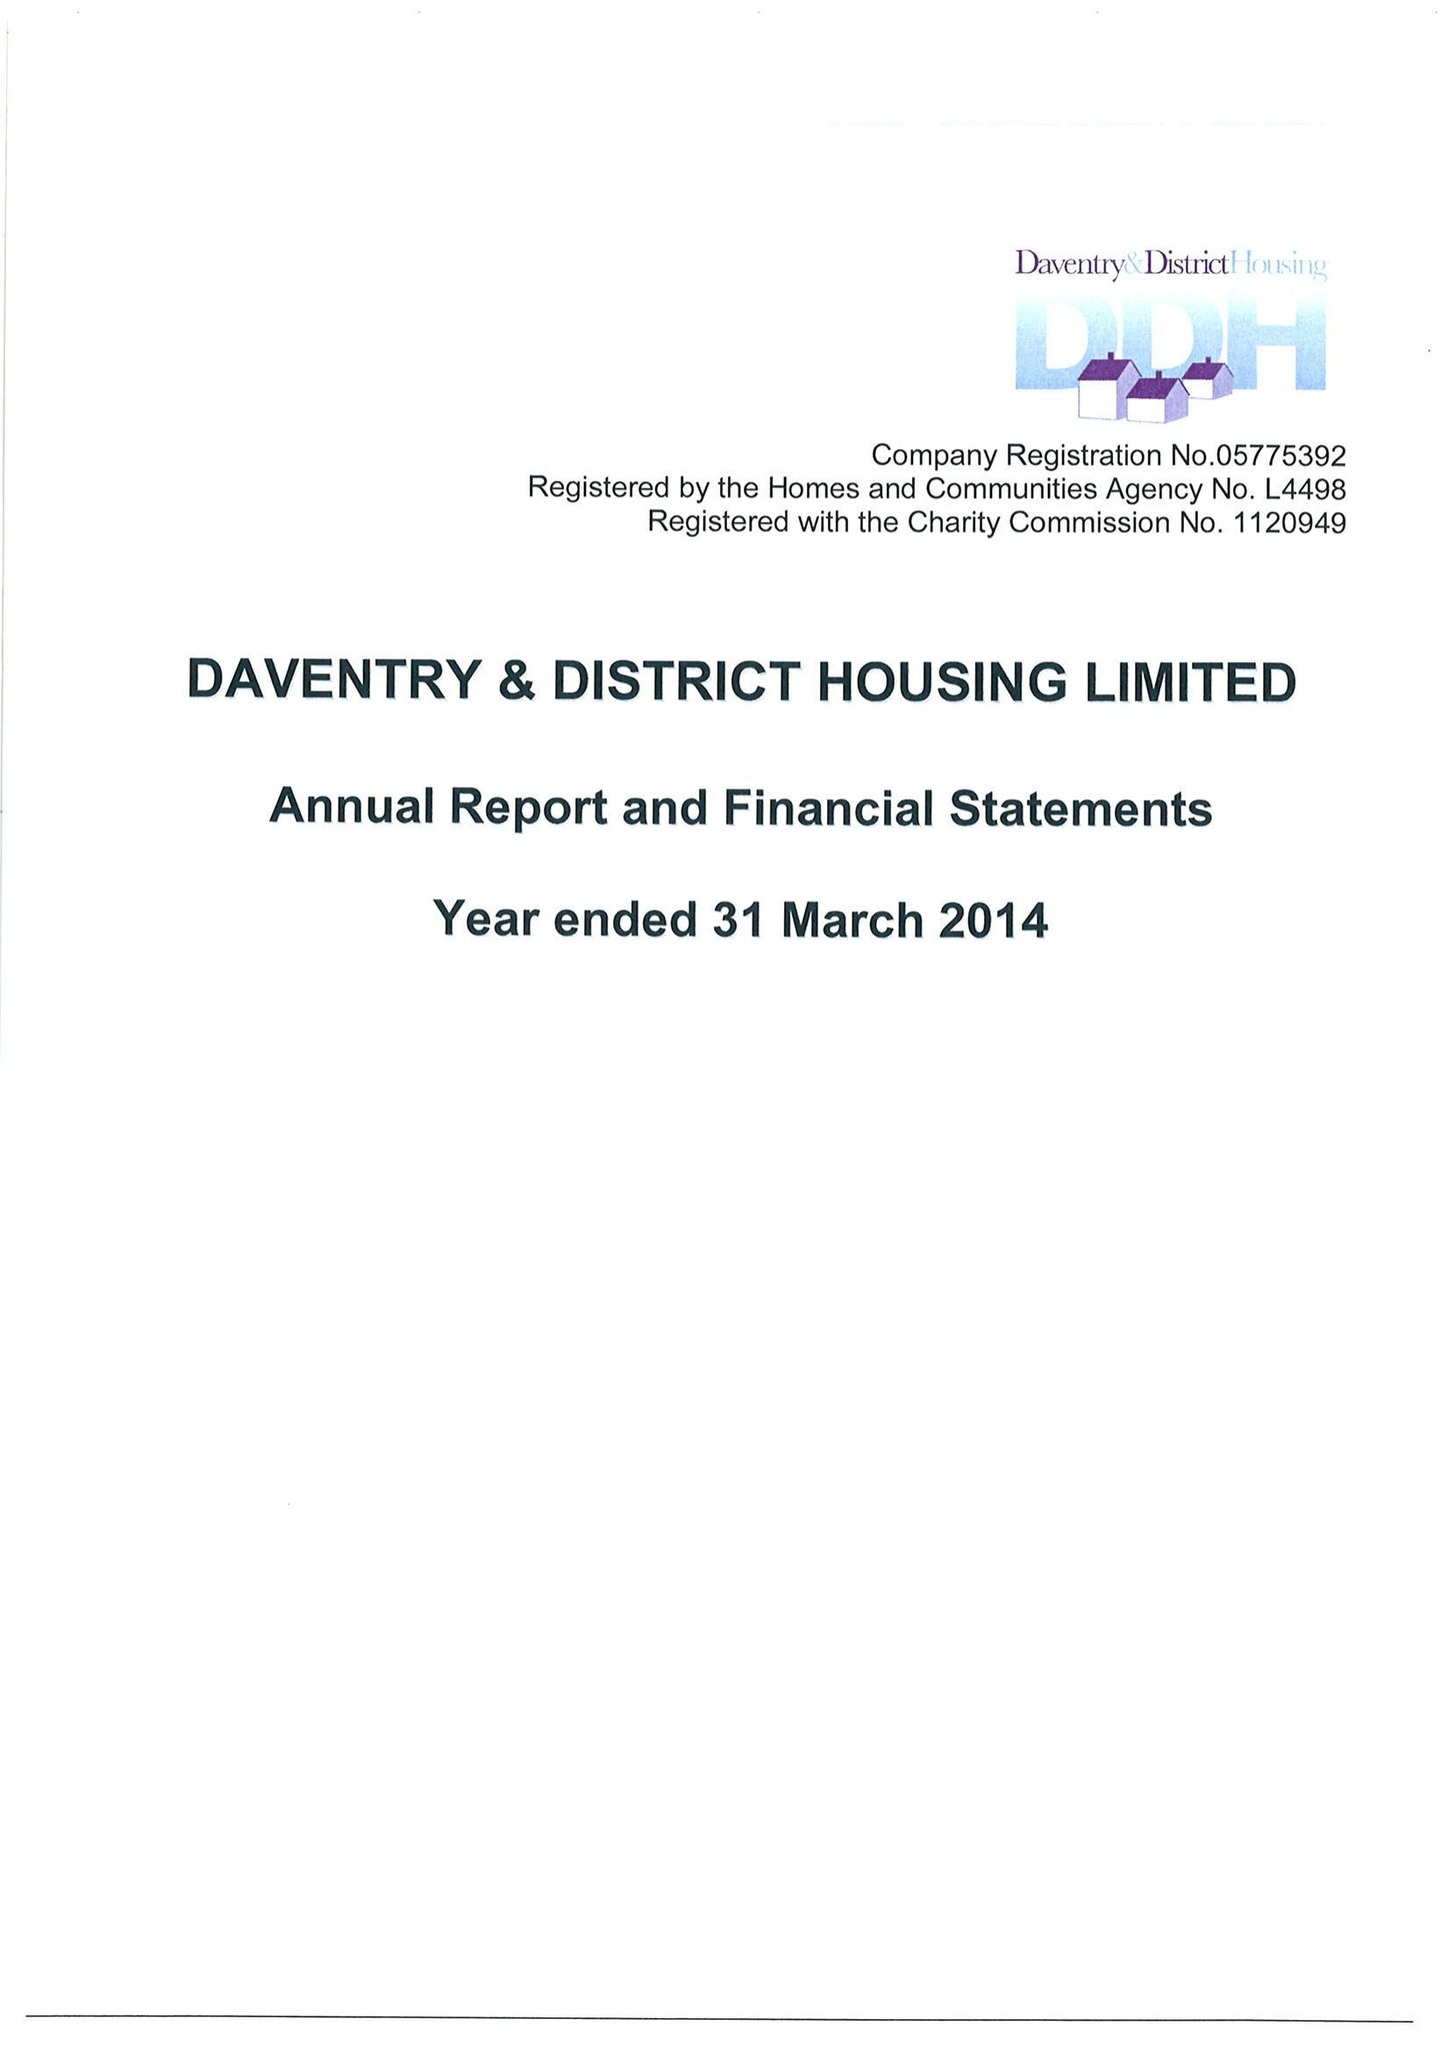What is the value for the charity_name?
Answer the question using a single word or phrase. Daventry and District Housing Ltd. 